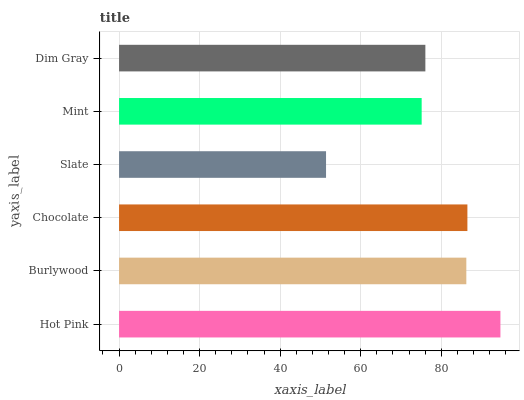Is Slate the minimum?
Answer yes or no. Yes. Is Hot Pink the maximum?
Answer yes or no. Yes. Is Burlywood the minimum?
Answer yes or no. No. Is Burlywood the maximum?
Answer yes or no. No. Is Hot Pink greater than Burlywood?
Answer yes or no. Yes. Is Burlywood less than Hot Pink?
Answer yes or no. Yes. Is Burlywood greater than Hot Pink?
Answer yes or no. No. Is Hot Pink less than Burlywood?
Answer yes or no. No. Is Burlywood the high median?
Answer yes or no. Yes. Is Dim Gray the low median?
Answer yes or no. Yes. Is Dim Gray the high median?
Answer yes or no. No. Is Slate the low median?
Answer yes or no. No. 